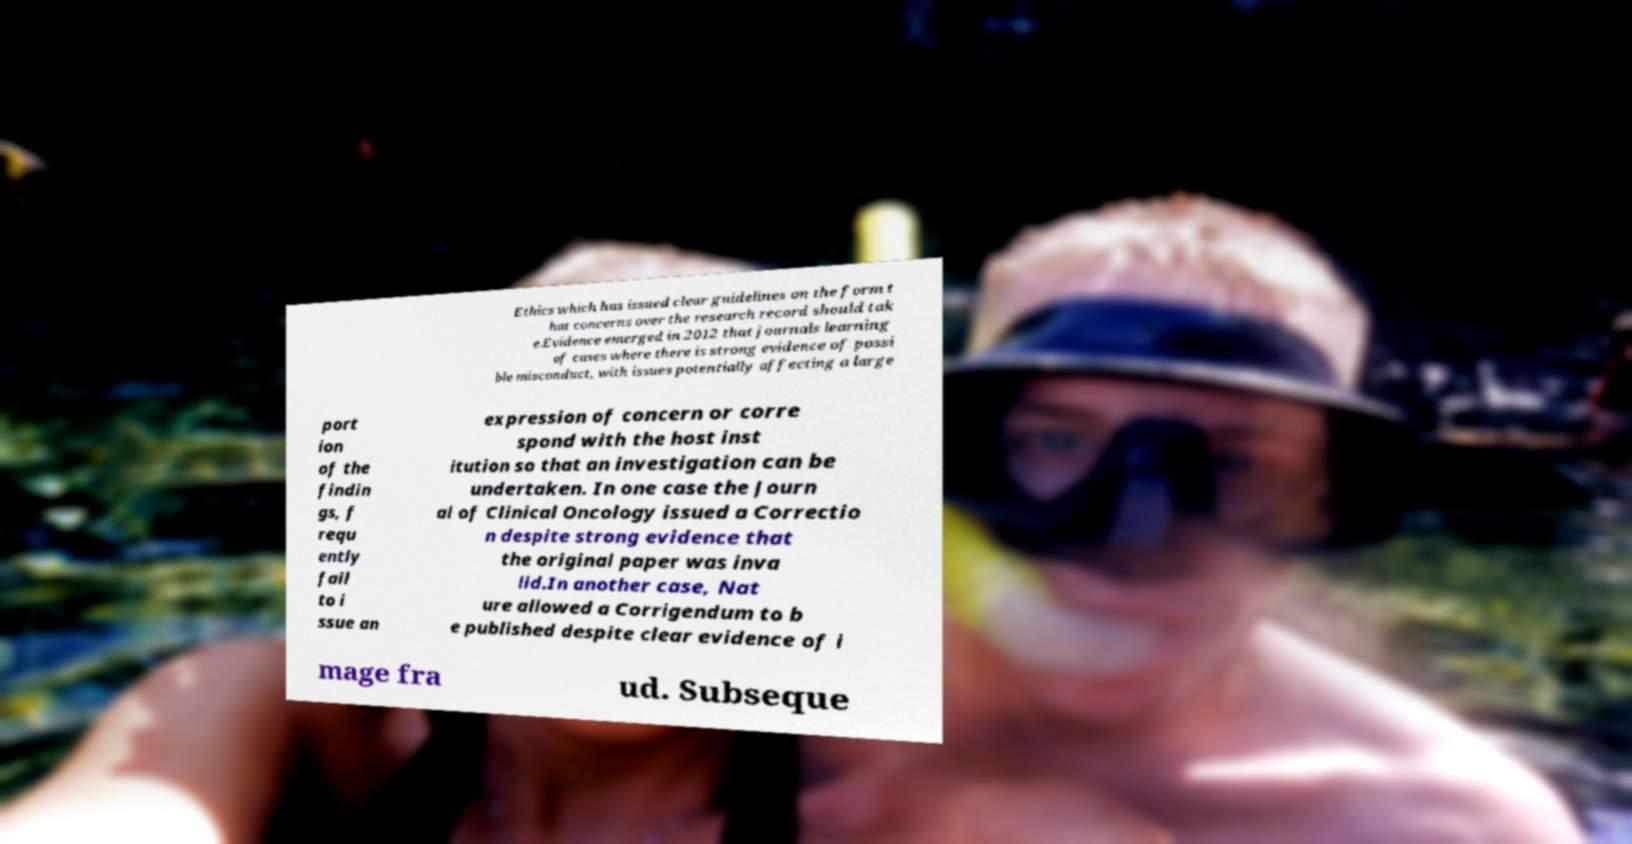Please identify and transcribe the text found in this image. Ethics which has issued clear guidelines on the form t hat concerns over the research record should tak e.Evidence emerged in 2012 that journals learning of cases where there is strong evidence of possi ble misconduct, with issues potentially affecting a large port ion of the findin gs, f requ ently fail to i ssue an expression of concern or corre spond with the host inst itution so that an investigation can be undertaken. In one case the Journ al of Clinical Oncology issued a Correctio n despite strong evidence that the original paper was inva lid.In another case, Nat ure allowed a Corrigendum to b e published despite clear evidence of i mage fra ud. Subseque 